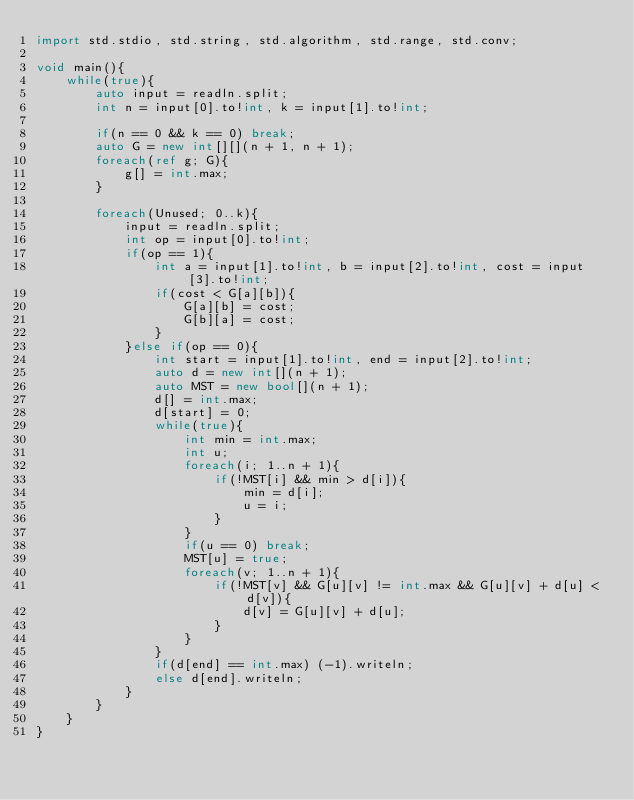Convert code to text. <code><loc_0><loc_0><loc_500><loc_500><_D_>import std.stdio, std.string, std.algorithm, std.range, std.conv;

void main(){
    while(true){
        auto input = readln.split;
        int n = input[0].to!int, k = input[1].to!int;

        if(n == 0 && k == 0) break;
        auto G = new int[][](n + 1, n + 1);
        foreach(ref g; G){
            g[] = int.max;
        }

        foreach(Unused; 0..k){
            input = readln.split;
            int op = input[0].to!int;
            if(op == 1){
                int a = input[1].to!int, b = input[2].to!int, cost = input[3].to!int;
                if(cost < G[a][b]){
                    G[a][b] = cost;
                    G[b][a] = cost;
                }
            }else if(op == 0){
                int start = input[1].to!int, end = input[2].to!int;
                auto d = new int[](n + 1);
                auto MST = new bool[](n + 1);
                d[] = int.max;
                d[start] = 0;
                while(true){
                    int min = int.max;
                    int u;
                    foreach(i; 1..n + 1){
                        if(!MST[i] && min > d[i]){
                            min = d[i];
                            u = i;
                        }
                    }
                    if(u == 0) break;
                    MST[u] = true;
                    foreach(v; 1..n + 1){
                        if(!MST[v] && G[u][v] != int.max && G[u][v] + d[u] < d[v]){
                            d[v] = G[u][v] + d[u];
                        }
                    }
                }
                if(d[end] == int.max) (-1).writeln;
                else d[end].writeln;
            }
        }
    }
}</code> 